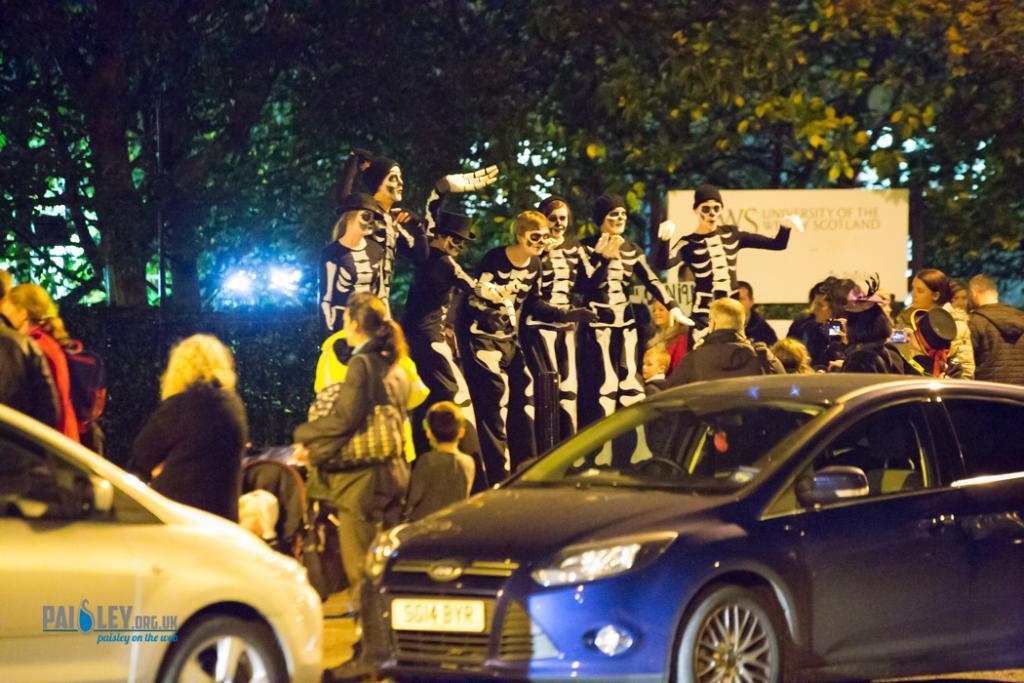Please provide a concise description of this image. In the center of the image we can see some people are standing and they are looks like halloween. In the background of the image we can see the trees, lights, boards, vehicles and some people are standing. At the bottom of the image we can see the road. 